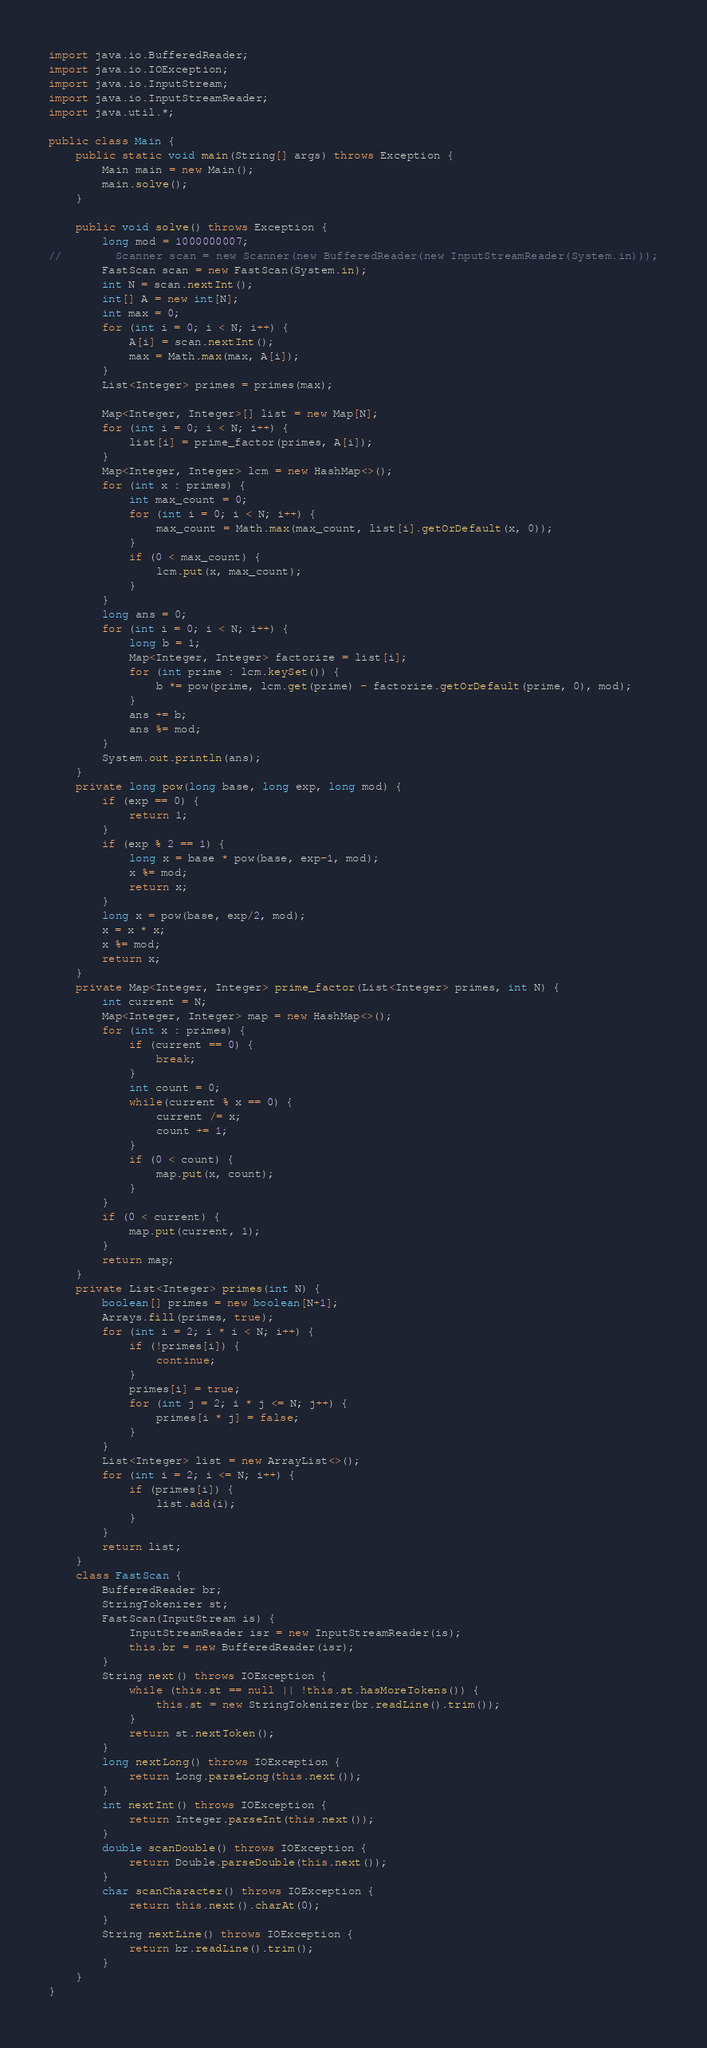<code> <loc_0><loc_0><loc_500><loc_500><_Java_>import java.io.BufferedReader;
import java.io.IOException;
import java.io.InputStream;
import java.io.InputStreamReader;
import java.util.*;

public class Main {
    public static void main(String[] args) throws Exception {
        Main main = new Main();
        main.solve();
    }

    public void solve() throws Exception {
        long mod = 1000000007;
//        Scanner scan = new Scanner(new BufferedReader(new InputStreamReader(System.in)));
        FastScan scan = new FastScan(System.in);
        int N = scan.nextInt();
        int[] A = new int[N];
        int max = 0;
        for (int i = 0; i < N; i++) {
            A[i] = scan.nextInt();
            max = Math.max(max, A[i]);
        }
        List<Integer> primes = primes(max);

        Map<Integer, Integer>[] list = new Map[N];
        for (int i = 0; i < N; i++) {
            list[i] = prime_factor(primes, A[i]);
        }
        Map<Integer, Integer> lcm = new HashMap<>();
        for (int x : primes) {
            int max_count = 0;
            for (int i = 0; i < N; i++) {
                max_count = Math.max(max_count, list[i].getOrDefault(x, 0));
            }
            if (0 < max_count) {
                lcm.put(x, max_count);
            }
        }
        long ans = 0;
        for (int i = 0; i < N; i++) {
            long b = 1;
            Map<Integer, Integer> factorize = list[i];
            for (int prime : lcm.keySet()) {
                b *= pow(prime, lcm.get(prime) - factorize.getOrDefault(prime, 0), mod);
            }
            ans += b;
            ans %= mod;
        }
        System.out.println(ans);
    }
    private long pow(long base, long exp, long mod) {
        if (exp == 0) {
            return 1;
        }
        if (exp % 2 == 1) {
            long x = base * pow(base, exp-1, mod);
            x %= mod;
            return x;
        }
        long x = pow(base, exp/2, mod);
        x = x * x;
        x %= mod;
        return x;
    }
    private Map<Integer, Integer> prime_factor(List<Integer> primes, int N) {
        int current = N;
        Map<Integer, Integer> map = new HashMap<>();
        for (int x : primes) {
            if (current == 0) {
                break;
            }
            int count = 0;
            while(current % x == 0) {
                current /= x;
                count += 1;
            }
            if (0 < count) {
                map.put(x, count);
            }
        }
        if (0 < current) {
            map.put(current, 1);
        }
        return map;
    }
    private List<Integer> primes(int N) {
        boolean[] primes = new boolean[N+1];
        Arrays.fill(primes, true);
        for (int i = 2; i * i < N; i++) {
            if (!primes[i]) {
                continue;
            }
            primes[i] = true;
            for (int j = 2; i * j <= N; j++) {
                primes[i * j] = false;
            }
        }
        List<Integer> list = new ArrayList<>();
        for (int i = 2; i <= N; i++) {
            if (primes[i]) {
                list.add(i);
            }
        }
        return list;
    }
    class FastScan {
        BufferedReader br;
        StringTokenizer st;
        FastScan(InputStream is) {
            InputStreamReader isr = new InputStreamReader(is);
            this.br = new BufferedReader(isr);
        }
        String next() throws IOException {
            while (this.st == null || !this.st.hasMoreTokens()) {
                this.st = new StringTokenizer(br.readLine().trim());
            }
            return st.nextToken();
        }
        long nextLong() throws IOException {
            return Long.parseLong(this.next());
        }
        int nextInt() throws IOException {
            return Integer.parseInt(this.next());
        }
        double scanDouble() throws IOException {
            return Double.parseDouble(this.next());
        }
        char scanCharacter() throws IOException {
            return this.next().charAt(0);
        }
        String nextLine() throws IOException {
            return br.readLine().trim();
        }
    }
}
</code> 